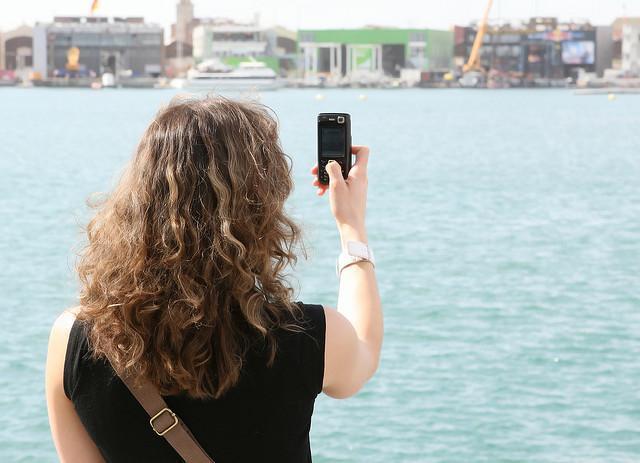Is this affirmation: "The person is far from the boat." correct?
Answer yes or no. Yes. 